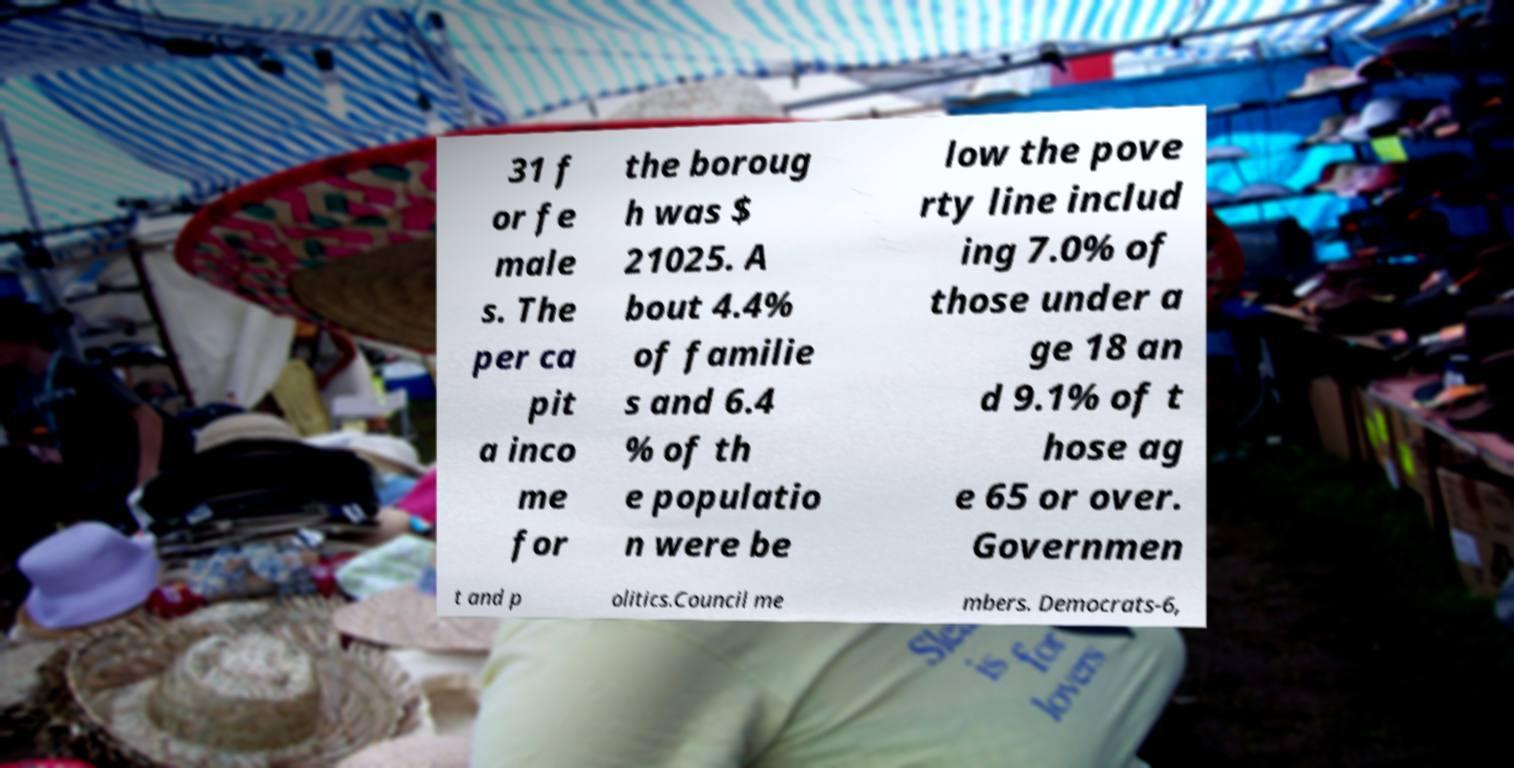Please identify and transcribe the text found in this image. 31 f or fe male s. The per ca pit a inco me for the boroug h was $ 21025. A bout 4.4% of familie s and 6.4 % of th e populatio n were be low the pove rty line includ ing 7.0% of those under a ge 18 an d 9.1% of t hose ag e 65 or over. Governmen t and p olitics.Council me mbers. Democrats-6, 